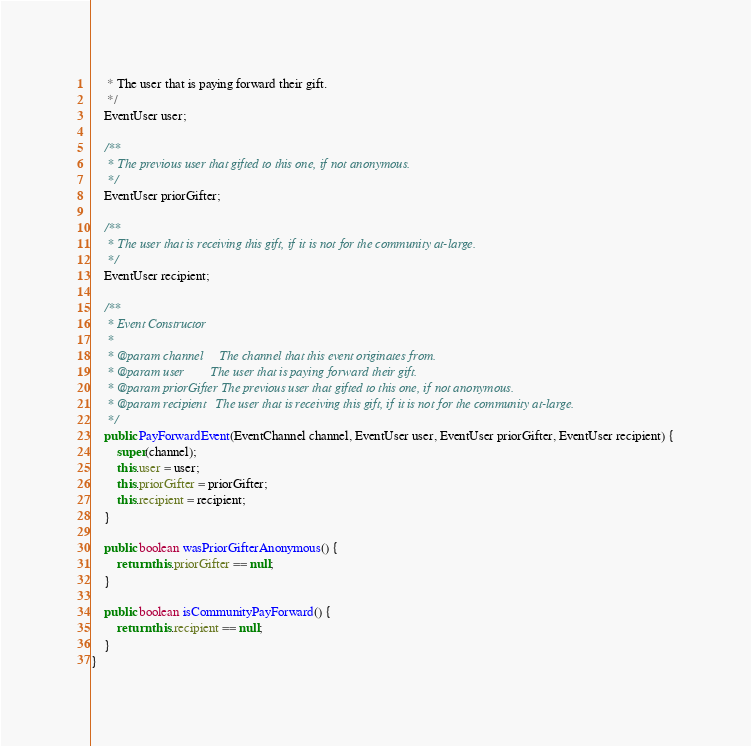<code> <loc_0><loc_0><loc_500><loc_500><_Java_>     * The user that is paying forward their gift.
     */
    EventUser user;

    /**
     * The previous user that gifted to this one, if not anonymous.
     */
    EventUser priorGifter;

    /**
     * The user that is receiving this gift, if it is not for the community at-large.
     */
    EventUser recipient;

    /**
     * Event Constructor
     *
     * @param channel     The channel that this event originates from.
     * @param user        The user that is paying forward their gift.
     * @param priorGifter The previous user that gifted to this one, if not anonymous.
     * @param recipient   The user that is receiving this gift, if it is not for the community at-large.
     */
    public PayForwardEvent(EventChannel channel, EventUser user, EventUser priorGifter, EventUser recipient) {
        super(channel);
        this.user = user;
        this.priorGifter = priorGifter;
        this.recipient = recipient;
    }

    public boolean wasPriorGifterAnonymous() {
        return this.priorGifter == null;
    }

    public boolean isCommunityPayForward() {
        return this.recipient == null;
    }
}
</code> 